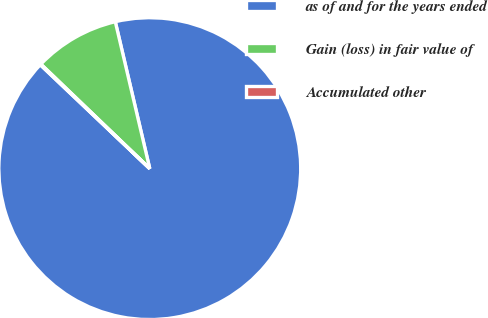Convert chart. <chart><loc_0><loc_0><loc_500><loc_500><pie_chart><fcel>as of and for the years ended<fcel>Gain (loss) in fair value of<fcel>Accumulated other<nl><fcel>90.75%<fcel>9.16%<fcel>0.09%<nl></chart> 